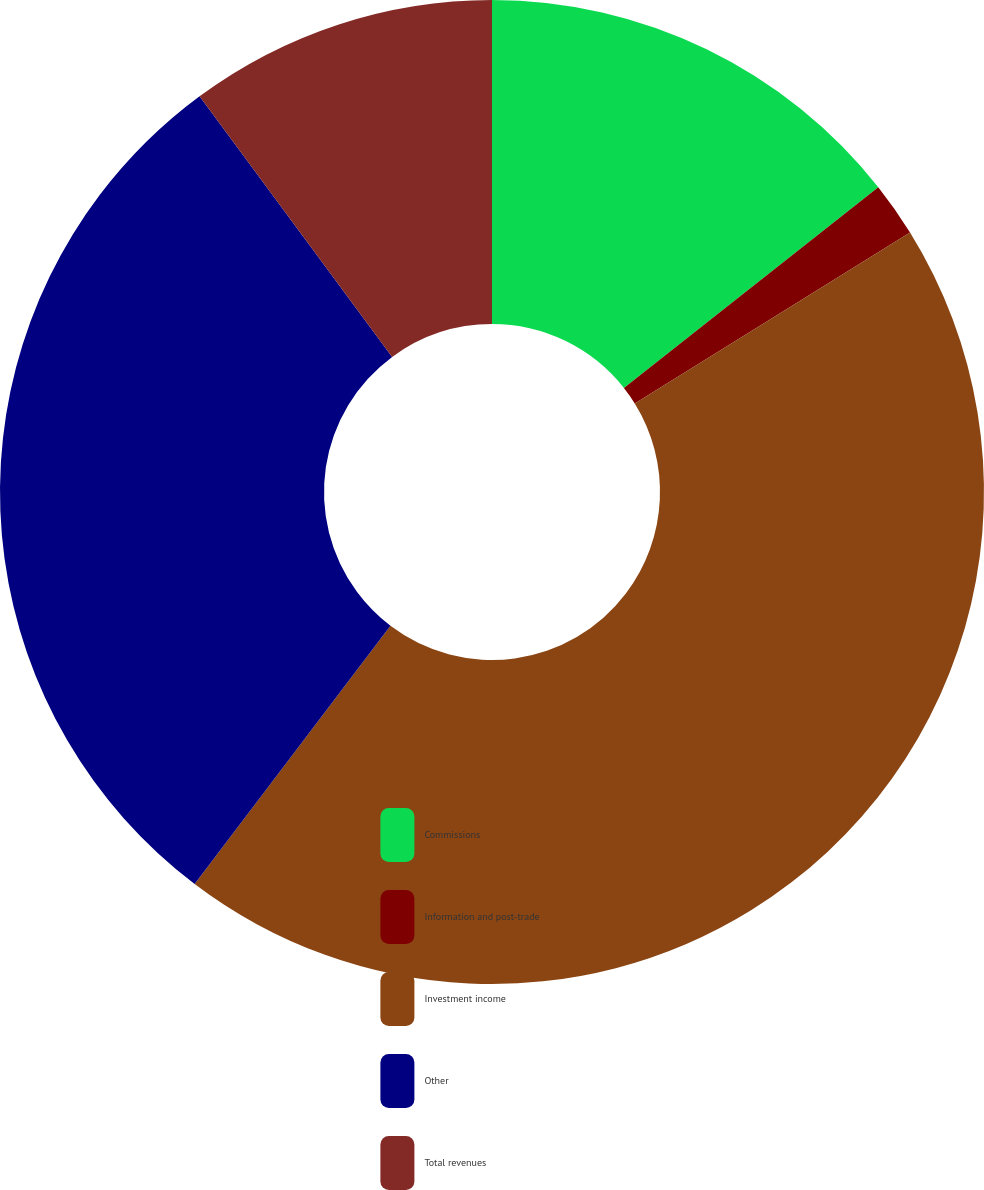Convert chart. <chart><loc_0><loc_0><loc_500><loc_500><pie_chart><fcel>Commissions<fcel>Information and post-trade<fcel>Investment income<fcel>Other<fcel>Total revenues<nl><fcel>14.37%<fcel>1.79%<fcel>44.17%<fcel>29.54%<fcel>10.13%<nl></chart> 